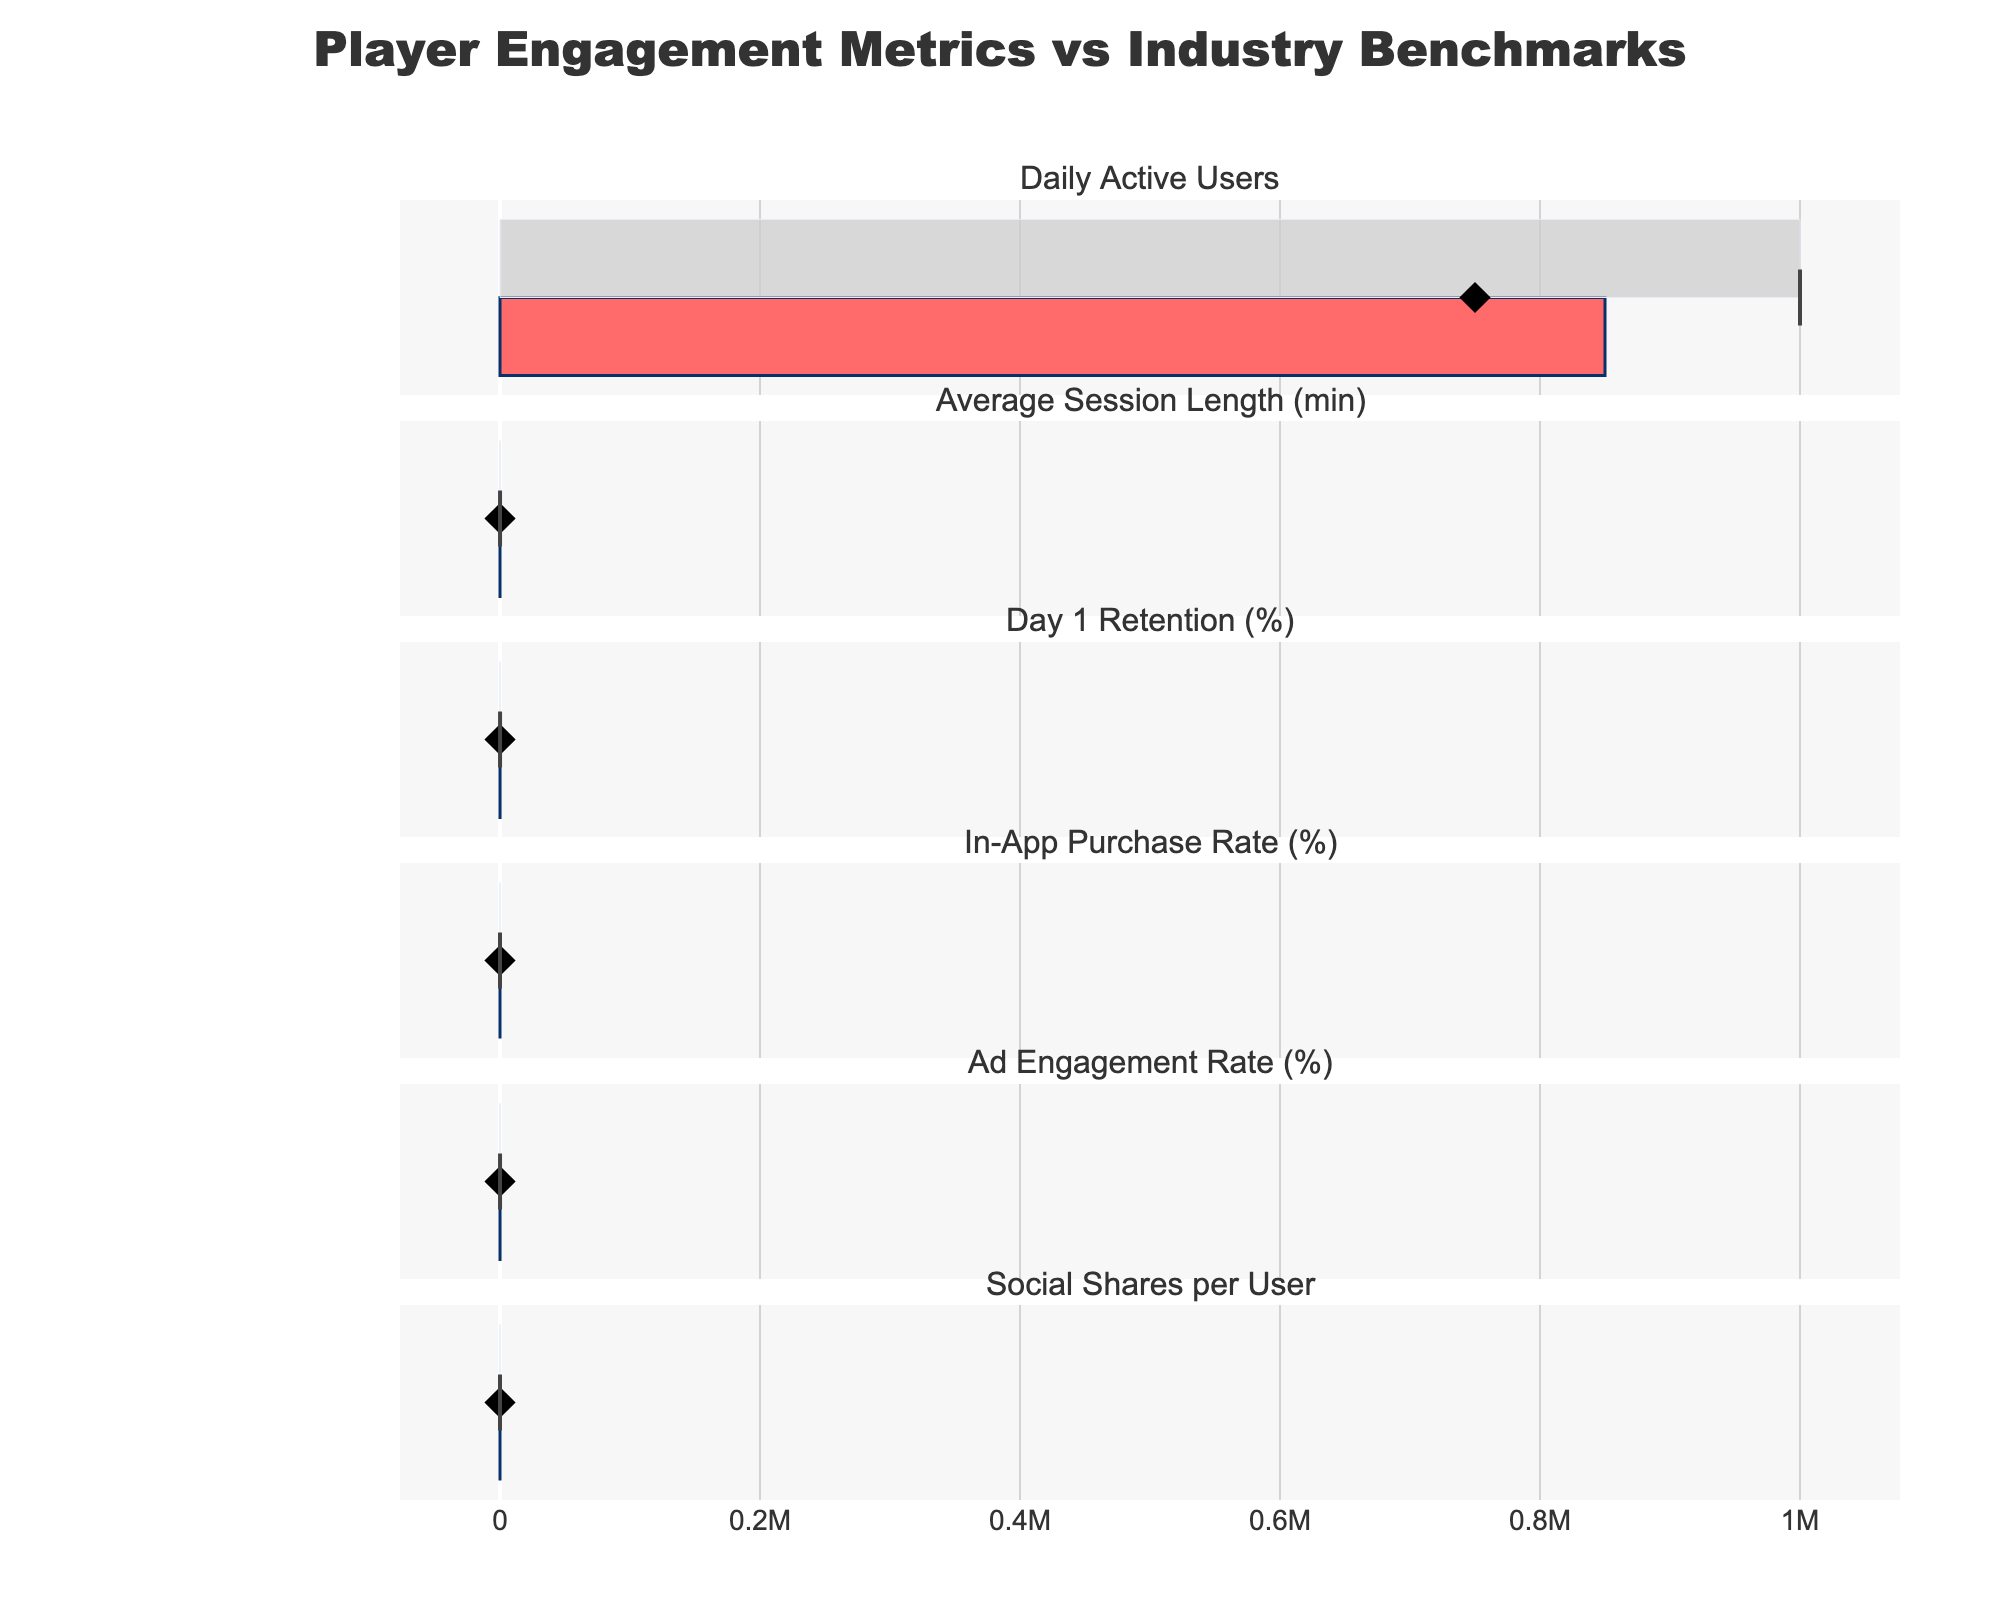What's the title of the figure? The title of the figure is displayed prominently at the top of the chart and reads "Player Engagement Metrics vs Industry Benchmarks".
Answer: Player Engagement Metrics vs Industry Benchmarks For the category 'Daily Active Users', what is the actual value? The actual value for 'Daily Active Users' is represented by the first bar in the respective subplot. It's shown as 850,000.
Answer: 850,000 What is the Comparative value for 'In-App Purchase Rate (%)'? The comparative value for 'In-App Purchase Rate (%)' is marked by a diamond symbol in the respective subplot and it is 4.5%.
Answer: 4.5% How much higher is the ‘Average Session Length’ actual value compared to the industry benchmark (Comparative value)? The actual value for ‘Average Session Length’ is 18 minutes and the industry benchmark (Comparative value) is 15 minutes. The difference is 18 - 15 = 3 minutes.
Answer: 3 minutes Compare the 'Day 1 Retention (%)' actual value to its target value. Is it above or below the target? The actual value for 'Day 1 Retention (%)' is shown at 42%, while the target value is marked by a red line at 50%. Since 42% is less than 50%, it is below the target.
Answer: Below Between 'Ad Engagement Rate (%)' and 'Social Shares per User', which metric shows a higher actual value? The actual value for 'Ad Engagement Rate (%)' is 28%, while for 'Social Shares per User' it is 0.8. Comparing these, 28% is higher than 0.8.
Answer: Ad Engagement Rate (%) Which metric's actual value is closest to its range's upper limit? 'In-App Purchase Rate (%)' has an actual value of 5.2%, and its upper limit is 8%. The difference for 'In-App Purchase Rate (%)' is smallest compared to the upper limits for other metrics.
Answer: In-App Purchase Rate (%) For the 'Daily Active Users' category, what is the percentage of the target value achieved by the actual value? The actual value for 'Daily Active Users' is 850,000, and the target is 1,000,000. The percentage achieved is calculated as (850,000 / 1,000,000) * 100 = 85%.
Answer: 85% Is the 'Day 1 Retention (%)' actual value within its designated range? The actual value for 'Day 1 Retention (%)' is 42%. The range provided is from 30% to 60%. Since 42% falls within this range, it is within the designated range.
Answer: Yes Which metric has the smallest comparative value, and what is it? The metrics' comparative values are compared and 'Social Shares per User' has the smallest comparative value of 0.6.
Answer: Social Shares per User, 0.6 